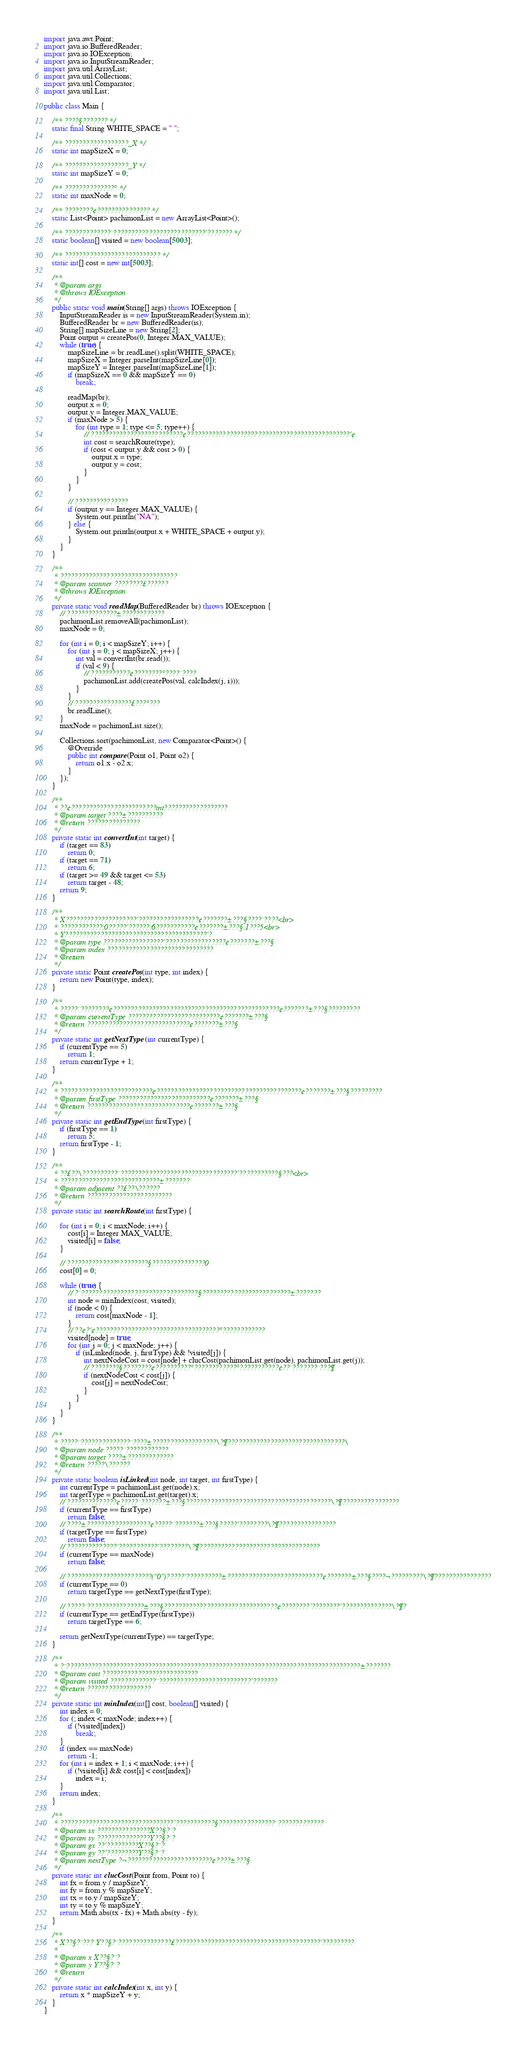<code> <loc_0><loc_0><loc_500><loc_500><_Java_>import java.awt.Point;
import java.io.BufferedReader;
import java.io.IOException;
import java.io.InputStreamReader;
import java.util.ArrayList;
import java.util.Collections;
import java.util.Comparator;
import java.util.List;

public class Main {

	/** ????§??????? */
	static final String WHITE_SPACE = " ";

	/** ??????????????????_X */
	static int mapSizeX = 0;

	/** ??????????????????_Y */
	static int mapSizeY = 0;

	/** ??????????????° */
	static int maxNode = 0;

	/** ????????¢??????????????? */
	static List<Point> pachimonList = new ArrayList<Point>();

	/** ?????????????¨??????????????????????????´??????? */
	static boolean[] visited = new boolean[5003];

	/** ??????????????????????????? */
	static int[] cost = new int[5003];

	/**
	 * @param args
	 * @throws IOException
	 */
	public static void main(String[] args) throws IOException {
		InputStreamReader is = new InputStreamReader(System.in);
		BufferedReader br = new BufferedReader(is);
		String[] mapSizeLine = new String[2];
		Point output = createPos(0, Integer.MAX_VALUE);
		while (true) {
			mapSizeLine = br.readLine().split(WHITE_SPACE);
			mapSizeX = Integer.parseInt(mapSizeLine[0]);
			mapSizeY = Integer.parseInt(mapSizeLine[1]);
			if (mapSizeX == 0 && mapSizeY == 0)
				break;

			readMap(br);
			output.x = 0;
			output.y = Integer.MAX_VALUE;
			if (maxNode > 5) {
				for (int type = 1; type <= 5; type++) {
					// ??????????????????????????¢??????????????????????????????????????????????´¢
					int cost = searchRoute(type);
					if (cost < output.y && cost > 0) {
						output.x = type;
						output.y = cost;
					}
				}
			}

			// ???????????????
			if (output.y == Integer.MAX_VALUE) {
				System.out.println("NA");
			} else {
				System.out.println(output.x + WHITE_SPACE + output.y);
			}
		}
	}

	/**
	 * ?????????????????????????????????
	 * @param scanner ????????£??????
	 * @throws IOException
	 */
	private static void readMap(BufferedReader br) throws IOException {
		// ??????????????±????????????
		pachimonList.removeAll(pachimonList);
		maxNode = 0;

		for (int i = 0; i < mapSizeY; i++) {
			for (int j = 0; j < mapSizeX; j++) {
				int val = convertInt(br.read());
				if (val < 9) {
					// ???????????¢????????°????¨????
					pachimonList.add(createPos(val, calcIndex(j, i)));
				}
			}
			// ????????????????£???°???
			br.readLine();
		}
		maxNode = pachimonList.size();

		Collections.sort(pachimonList, new Comparator<Point>() {
			@Override
			public int compare(Point o1, Point o2) {
				return o1.x - o2.x;
			}
		});
	}

	/**
	 * ??¢????????????????????????int??????????????????
	 * @param target ????±??????????
	 * @return ???????????????
	 */
	private static int convertInt(int target) {
		if (target == 83)
			return 0;
		if (target == 71)
			return 6;
		if (target >= 49 && target <= 53)
			return target - 48;
		return 9;
	}

	/**
	 * X????????????????????´?????????????????¢???????±???§????¨????<br>
	 * ????????????:0?????´??????:6???????????¢???????±???§:1???5<br>
	 * Y????????????????????????????????????????´?
	 * @param type ?????????????????´?????????????????¢???????±???§
	 * @param index ??????????????????????????????
	 * @return
	 */
	private static Point createPos(int type, int index) {
		return new Point(type, index);
	}

	/**
	 * ?????¨????????¢???????????????????????????????????????????????¢???????±???§?????????
	 * @param currentType ??????????????????????????¢???????±???§
	 * @return ?????????????????????????????¢???????±???§
	 */
	private static int getNextType(int currentType) {
		if (currentType == 5)
			return 1;
		return currentType + 1;
	}

	/**
	 * ??????????????????????????¢?????????????????????????????????????????¢???????±???§?????????
	 * @param firstType ??????????????????????????¢???????±???§
	 * @return ?????????????????????????????¢???????±???§
	 */
	private static int getEndType(int firstType) {
		if (firstType == 1)
			return 5;
		return firstType - 1;
	}

	/**
	 * ??£??\??????????¨?????????????????????????????????´???????????§???<br>
	 * ????????????????????????????±???????
	 * @param adjacent ??£??\??????
	 * @return ????????????????????????
	 */
	private static int searchRoute(int firstType) {

		for (int i = 0; i < maxNode; i++) {
			cost[i] = Integer.MAX_VALUE;
			visited[i] = false;
		}

		// ??????????????°????????§???????????????0
		cost[0] = 0;

		while (true) {
			// ?¨?????????????????????????????????§?????????????????????????±???????
			int node = minIndex(cost, visited);
			if (node < 0) {
				return cost[maxNode - 1];
			}
			// ??¢?´¢???????????????????????????????????°????????????
			visited[node] = true;
			for (int j = 0; j < maxNode; j++) {
				if (isLinked(node, j, firstType) && !visited[j]) {
					int nextNodeCost = cost[node] + clucCost(pachimonList.get(node), pachimonList.get(j));
					// ????????§????????¢??????????°????????????°???????????¢??¨???????¨???¶
					if (nextNodeCost < cost[j]) {
						cost[j] = nextNodeCost;
					}
				}
			}
		}
	}

	/**
	 * ?????¨??????????????¨????±??????????????????\?¶?????????????????????????????????\
	 * @param node ?????¨????????????
	 * @param target ????±?????????????
	 * @return ?????\??????
	 */
	private static boolean isLinked(int node, int target, int firstType) {
		int currentType = pachimonList.get(node).x;
		int targetType = pachimonList.get(target).x;
		// ??????????????¢?????¨???????±???§?????????????????????????????????????????\?¶????????????????
		if (currentType == firstType)
			return false;
		// ????±??????????????????¢?????¨???????±???§?????´????????\?¶????????????????
		if (targetType == firstType)
			return false;
		// ??????????????´???????????´????????\?¶??????????????????????????????????
		if (currentType == maxNode)
			return false;

		// ????????????????????????("0")?????´??????????±???????????????????????????¢???????±???§????¬?????????\?¶????????????????
		if (currentType == 0)
			return targetType == getNextType(firstType);

		// ?????¨????????????????±???§????????????????????????????????¢????????´????????´??????????????\?¶?
		if (currentType == getEndType(firstType))
			return targetType == 6;

		return getNextType(currentType) == targetType;
	}

	/**
	 * ?¨???????????????????????????????????????????????????????????????????????????????????±???????
	 * @param cost ???????????????????????????
	 * @param visited ?????????????¨??????????????????????????´???????
	 * @return ??????????????????
	 */
	private static int minIndex(int[] cost, boolean[] visited) {
		int index = 0;
		for (; index < maxNode; index++) {
			if (!visited[index])
				break;
		}
		if (index == maxNode)
			return -1;
		for (int i = index + 1; i < maxNode; i++) {
			if (!visited[i] && cost[i] < cost[index])
				index = i;
		}
		return index;
	}

	/**
	 * ????????????????????????????????´???????????§????????????????¨?????????????
	 * @param sx ???????????????X??§?¨?
	 * @param sy ???????????????Y??§?¨?
	 * @param gx ??´?????????X??§?¨?
	 * @param gy ??´?????????Y??§?¨?
	 * @param nextType ?¬????????????????????????¢????±???§
	 */
	private static int clucCost(Point from, Point to) {
		int fx = from.y / mapSizeY;
		int fy = from.y % mapSizeY;
		int tx = to.y / mapSizeY;
		int ty = to.y % mapSizeY;
		return Math.abs(tx - fx) + Math.abs(ty - fy);
	}

	/**
	 * X??§?¨???¨Y??§?¨???????????????£?????????????????????????????????????????´?????????
	 *
	 * @param x X??§?¨?
	 * @param y Y??§?¨?
	 * @return
	 */
	private static int calcIndex(int x, int y) {
		return x * mapSizeY + y;
	}
}</code> 